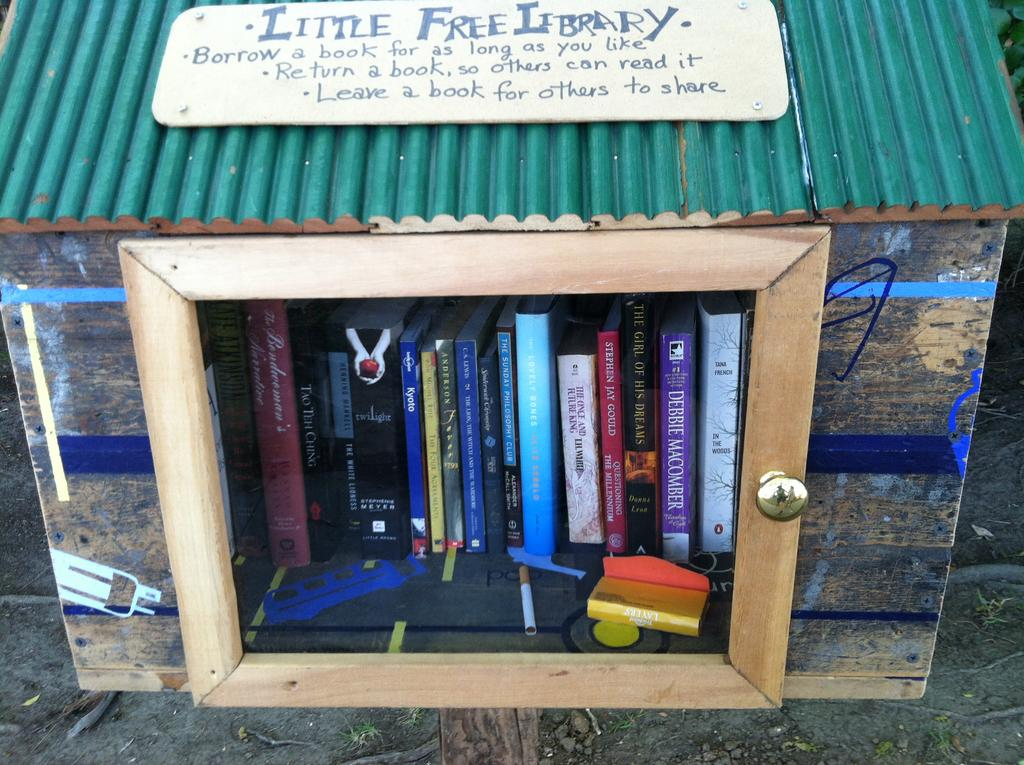<image>
Create a compact narrative representing the image presented. A small box that is called the Little Free Library 